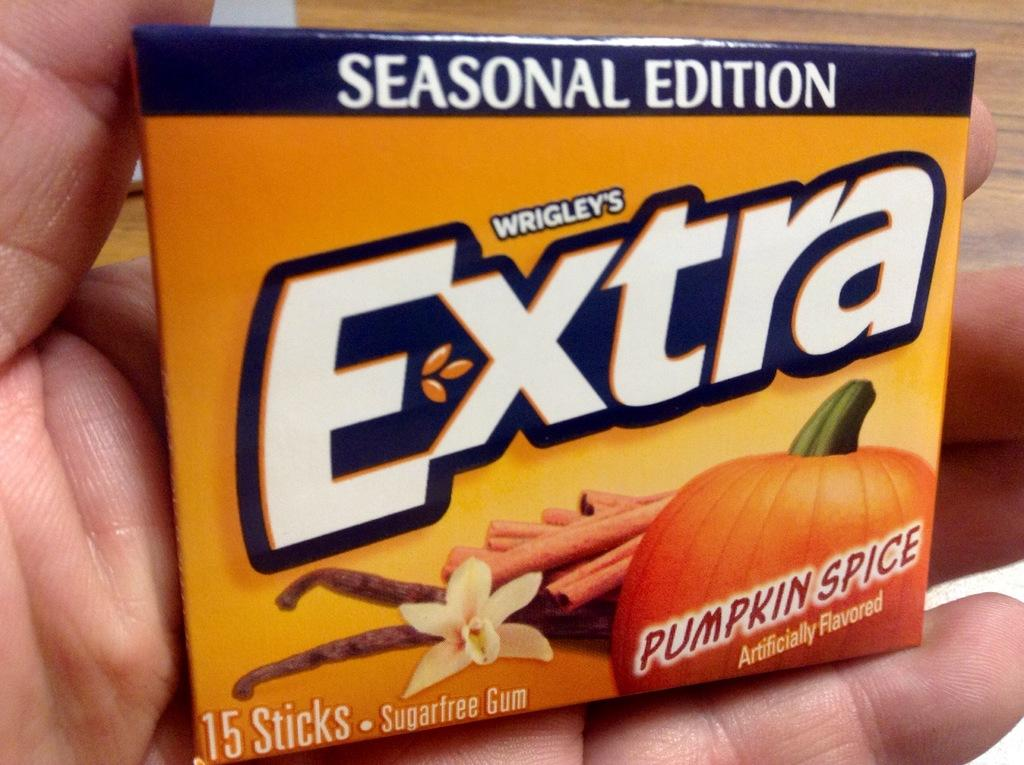Provide a one-sentence caption for the provided image. Pack of Wrigley's  extra gum  sugar-free in the seasonal edition flavor of pumpkin spice. 